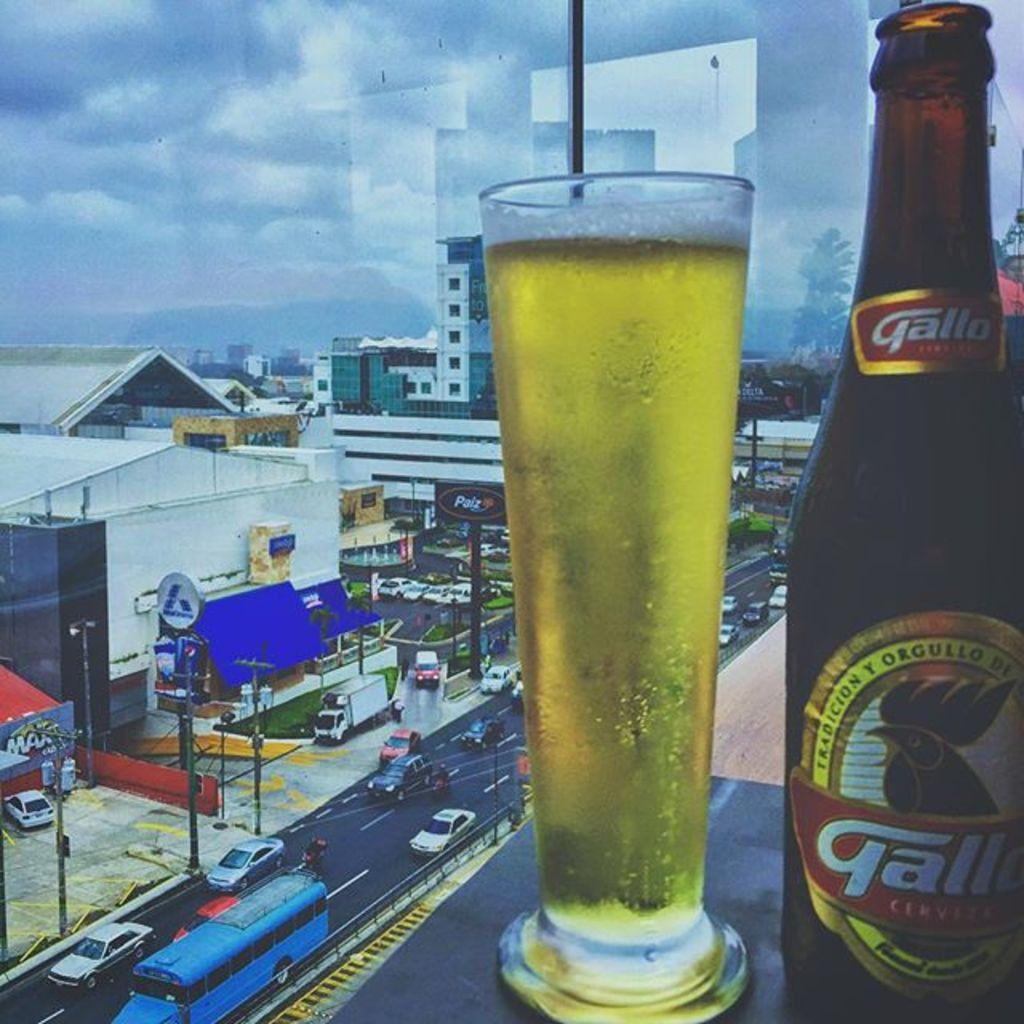What is in the glass that is visible in the image? There is a glass with liquid in the image. What other objects can be seen in the image? There is a bottle, buildings, posters, poles, trees, and grass visible in the image. What is the sky's condition in the image? The sky is visible in the image, and there are clouds present. What channel is the disease being broadcasted on in the image? There is no mention of a disease or a channel in the image; it features a glass with liquid, a bottle, buildings, posters, poles, trees, grass, and a sky with clouds. 